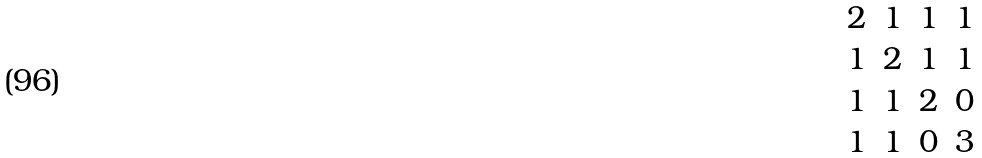<formula> <loc_0><loc_0><loc_500><loc_500>\begin{matrix} 2 & 1 & 1 & 1 \\ 1 & 2 & 1 & 1 \\ 1 & 1 & 2 & 0 \\ 1 & 1 & 0 & 3 \end{matrix}</formula> 